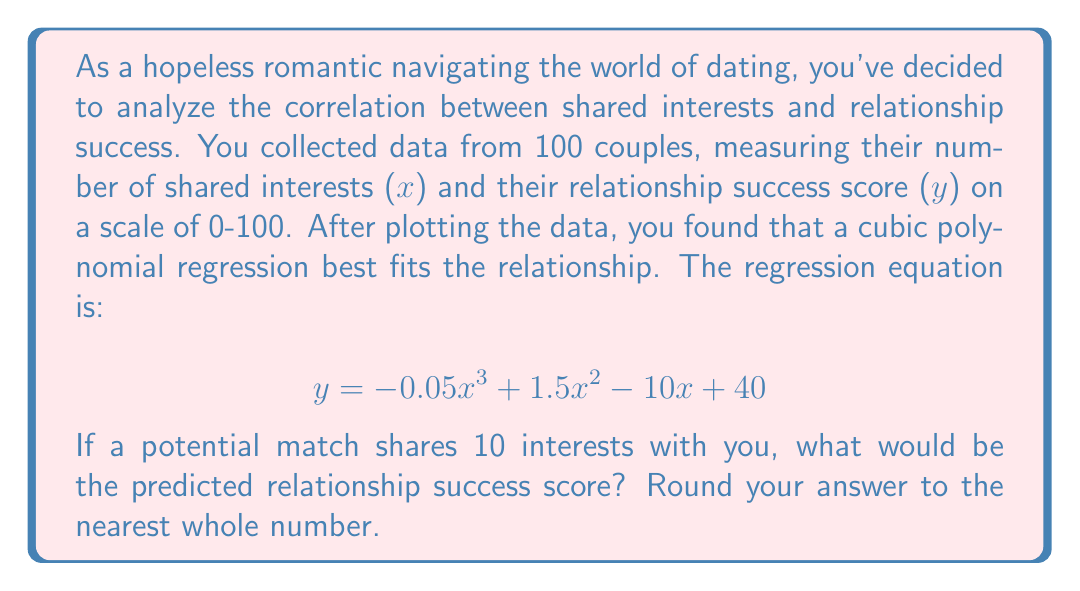Show me your answer to this math problem. To solve this problem, we need to use the given cubic polynomial regression equation and substitute x with 10 (the number of shared interests).

Let's break it down step by step:

1. The equation is: $y = -0.05x^3 + 1.5x^2 - 10x + 40$

2. Substitute x with 10:
   $y = -0.05(10)^3 + 1.5(10)^2 - 10(10) + 40$

3. Simplify the exponents:
   $y = -0.05(1000) + 1.5(100) - 10(10) + 40$

4. Multiply:
   $y = -50 + 150 - 100 + 40$

5. Add the terms:
   $y = 40$

Therefore, the predicted relationship success score for a potential match with 10 shared interests is 40.

Since the question asks to round to the nearest whole number, and 40 is already a whole number, no further rounding is necessary.
Answer: 40 